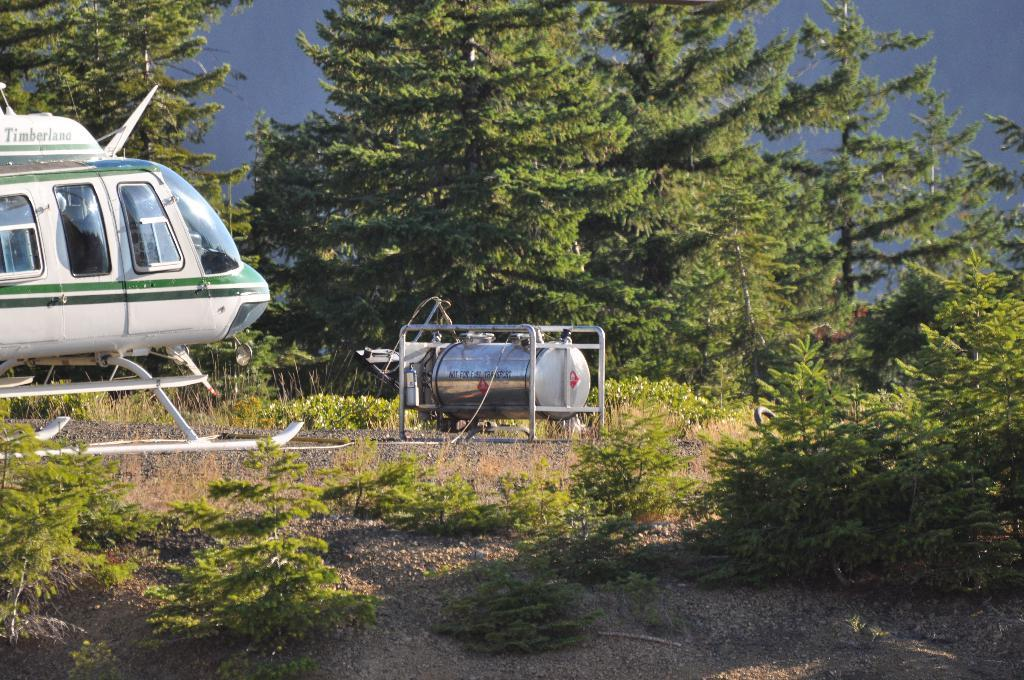What is the main subject of the image? There is a helicopter in the image. What else can be seen on the ground in the image? There are plants on the ground in the image. What is visible in the background of the image? There are trees and the sky visible in the background of the image. What type of book is being read by the helicopter in the image? There is no book or person reading in the image; it features a helicopter and other elements. 